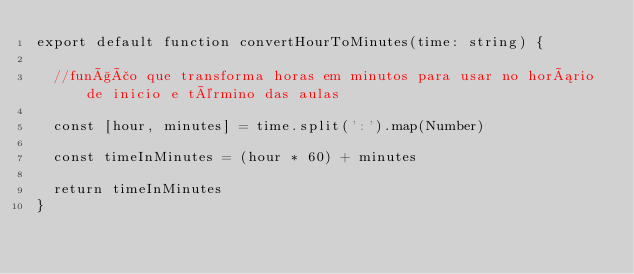Convert code to text. <code><loc_0><loc_0><loc_500><loc_500><_TypeScript_>export default function convertHourToMinutes(time: string) {
  
  //função que transforma horas em minutos para usar no horário de inicio e término das aulas

  const [hour, minutes] = time.split(':').map(Number)

  const timeInMinutes = (hour * 60) + minutes

  return timeInMinutes
}</code> 